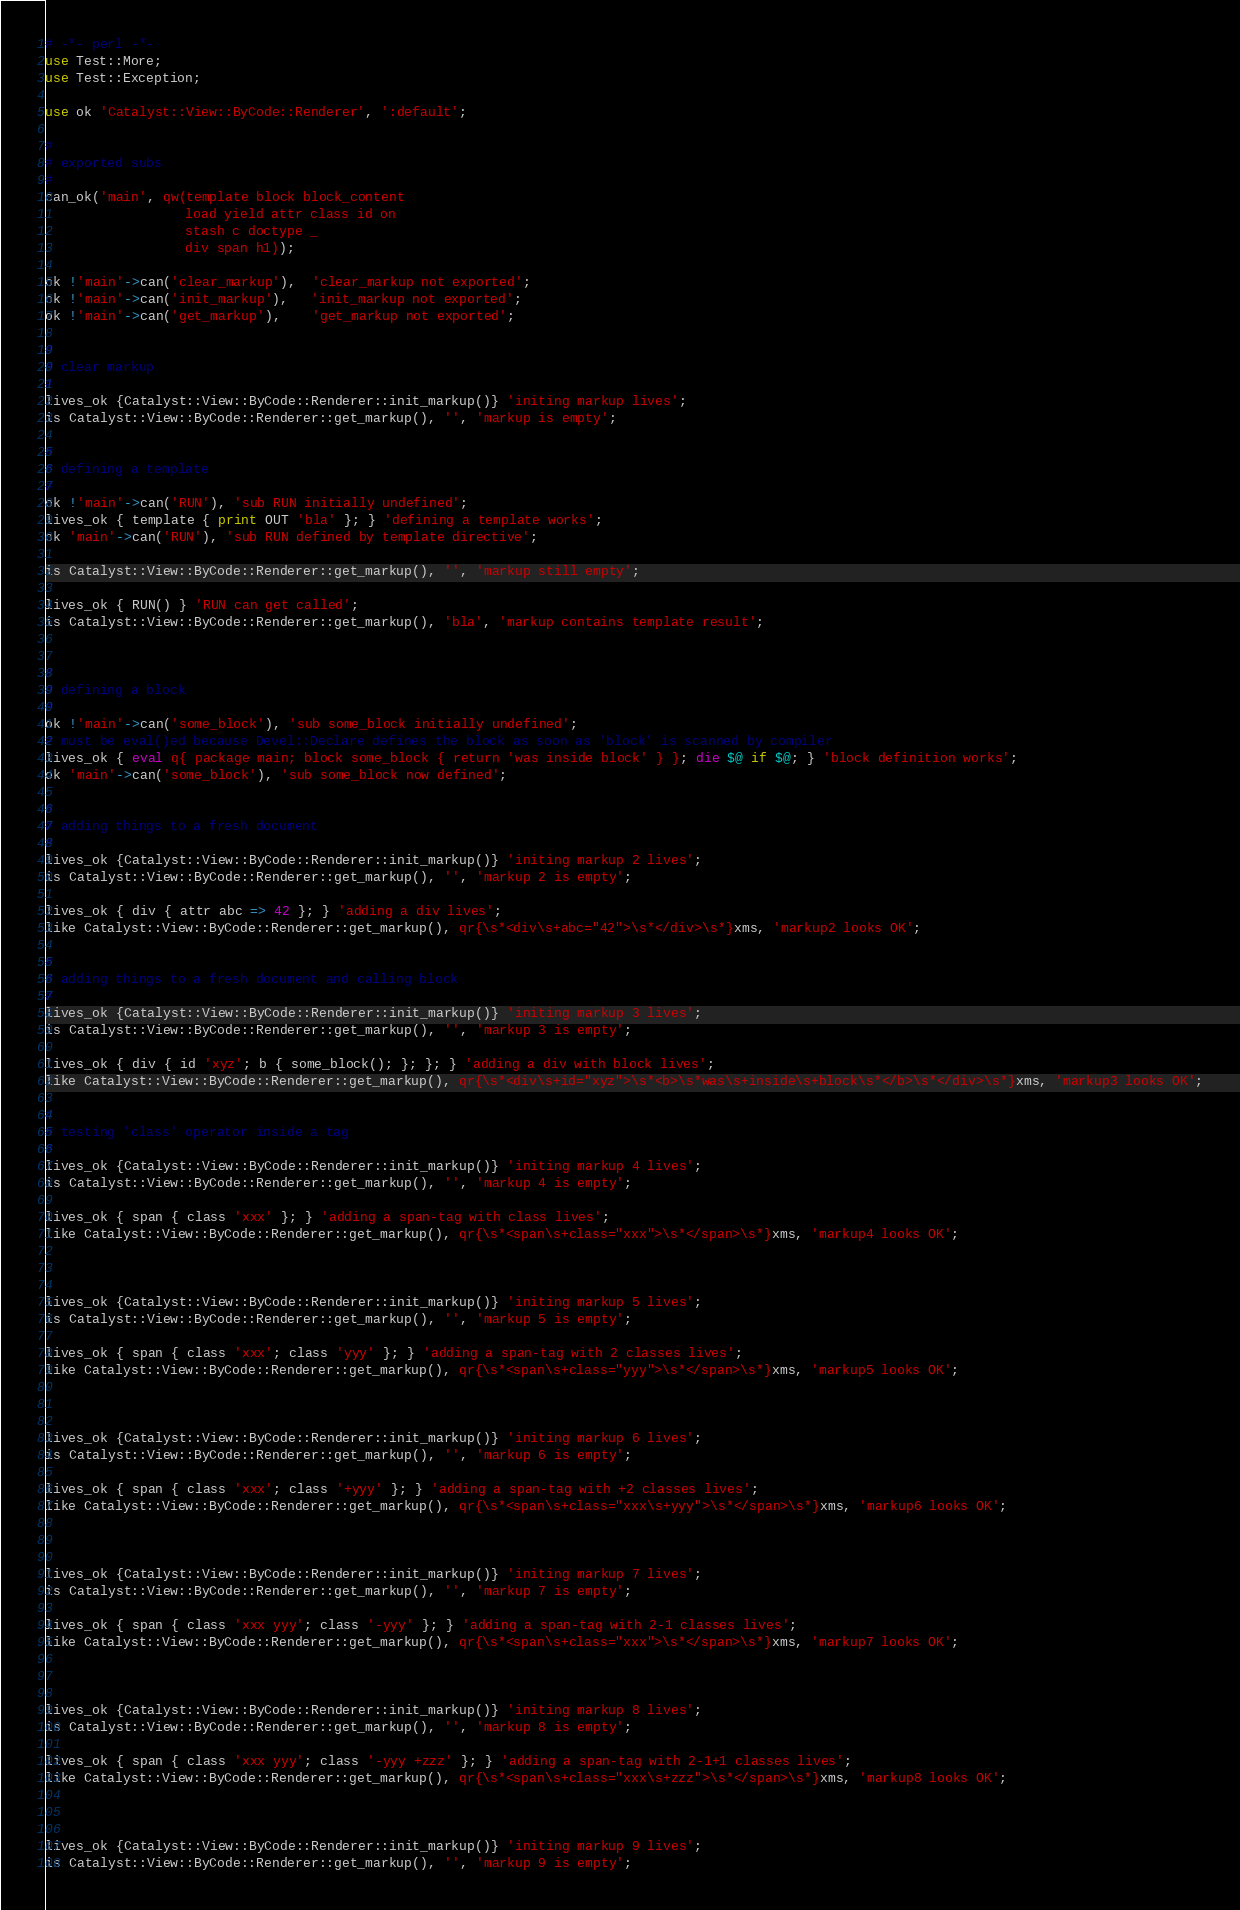<code> <loc_0><loc_0><loc_500><loc_500><_Perl_># -*- perl -*-
use Test::More;
use Test::Exception;

use ok 'Catalyst::View::ByCode::Renderer', ':default';

#
# exported subs
#
can_ok('main', qw(template block block_content
                  load yield attr class id on
                  stash c doctype _
                  div span h1));

ok !'main'->can('clear_markup'),  'clear_markup not exported';
ok !'main'->can('init_markup'),   'init_markup not exported';
ok !'main'->can('get_markup'),    'get_markup not exported';

#
# clear markup
#
lives_ok {Catalyst::View::ByCode::Renderer::init_markup()} 'initing markup lives';
is Catalyst::View::ByCode::Renderer::get_markup(), '', 'markup is empty';

#
# defining a template
#
ok !'main'->can('RUN'), 'sub RUN initially undefined';
lives_ok { template { print OUT 'bla' }; } 'defining a template works';
ok 'main'->can('RUN'), 'sub RUN defined by template directive';

is Catalyst::View::ByCode::Renderer::get_markup(), '', 'markup still empty';

lives_ok { RUN() } 'RUN can get called';
is Catalyst::View::ByCode::Renderer::get_markup(), 'bla', 'markup contains template result';


#
# defining a block
#
ok !'main'->can('some_block'), 'sub some_block initially undefined';
# must be eval()ed because Devel::Declare defines the block as soon as 'block' is scanned by compiler
lives_ok { eval q{ package main; block some_block { return 'was inside block' } }; die $@ if $@; } 'block definition works';
ok 'main'->can('some_block'), 'sub some_block now defined';

#
# adding things to a fresh document
#
lives_ok {Catalyst::View::ByCode::Renderer::init_markup()} 'initing markup 2 lives';
is Catalyst::View::ByCode::Renderer::get_markup(), '', 'markup 2 is empty';

lives_ok { div { attr abc => 42 }; } 'adding a div lives';
like Catalyst::View::ByCode::Renderer::get_markup(), qr{\s*<div\s+abc="42">\s*</div>\s*}xms, 'markup2 looks OK';

#
# adding things to a fresh document and calling block
#
lives_ok {Catalyst::View::ByCode::Renderer::init_markup()} 'initing markup 3 lives';
is Catalyst::View::ByCode::Renderer::get_markup(), '', 'markup 3 is empty';

lives_ok { div { id 'xyz'; b { some_block(); }; }; } 'adding a div with block lives';
like Catalyst::View::ByCode::Renderer::get_markup(), qr{\s*<div\s+id="xyz">\s*<b>\s*was\s+inside\s+block\s*</b>\s*</div>\s*}xms, 'markup3 looks OK';

#
# testing 'class' operator inside a tag
#
lives_ok {Catalyst::View::ByCode::Renderer::init_markup()} 'initing markup 4 lives';
is Catalyst::View::ByCode::Renderer::get_markup(), '', 'markup 4 is empty';

lives_ok { span { class 'xxx' }; } 'adding a span-tag with class lives';
like Catalyst::View::ByCode::Renderer::get_markup(), qr{\s*<span\s+class="xxx">\s*</span>\s*}xms, 'markup4 looks OK';



lives_ok {Catalyst::View::ByCode::Renderer::init_markup()} 'initing markup 5 lives';
is Catalyst::View::ByCode::Renderer::get_markup(), '', 'markup 5 is empty';

lives_ok { span { class 'xxx'; class 'yyy' }; } 'adding a span-tag with 2 classes lives';
like Catalyst::View::ByCode::Renderer::get_markup(), qr{\s*<span\s+class="yyy">\s*</span>\s*}xms, 'markup5 looks OK';



lives_ok {Catalyst::View::ByCode::Renderer::init_markup()} 'initing markup 6 lives';
is Catalyst::View::ByCode::Renderer::get_markup(), '', 'markup 6 is empty';

lives_ok { span { class 'xxx'; class '+yyy' }; } 'adding a span-tag with +2 classes lives';
like Catalyst::View::ByCode::Renderer::get_markup(), qr{\s*<span\s+class="xxx\s+yyy">\s*</span>\s*}xms, 'markup6 looks OK';



lives_ok {Catalyst::View::ByCode::Renderer::init_markup()} 'initing markup 7 lives';
is Catalyst::View::ByCode::Renderer::get_markup(), '', 'markup 7 is empty';

lives_ok { span { class 'xxx yyy'; class '-yyy' }; } 'adding a span-tag with 2-1 classes lives';
like Catalyst::View::ByCode::Renderer::get_markup(), qr{\s*<span\s+class="xxx">\s*</span>\s*}xms, 'markup7 looks OK';



lives_ok {Catalyst::View::ByCode::Renderer::init_markup()} 'initing markup 8 lives';
is Catalyst::View::ByCode::Renderer::get_markup(), '', 'markup 8 is empty';

lives_ok { span { class 'xxx yyy'; class '-yyy +zzz' }; } 'adding a span-tag with 2-1+1 classes lives';
like Catalyst::View::ByCode::Renderer::get_markup(), qr{\s*<span\s+class="xxx\s+zzz">\s*</span>\s*}xms, 'markup8 looks OK';



lives_ok {Catalyst::View::ByCode::Renderer::init_markup()} 'initing markup 9 lives';
is Catalyst::View::ByCode::Renderer::get_markup(), '', 'markup 9 is empty';
</code> 